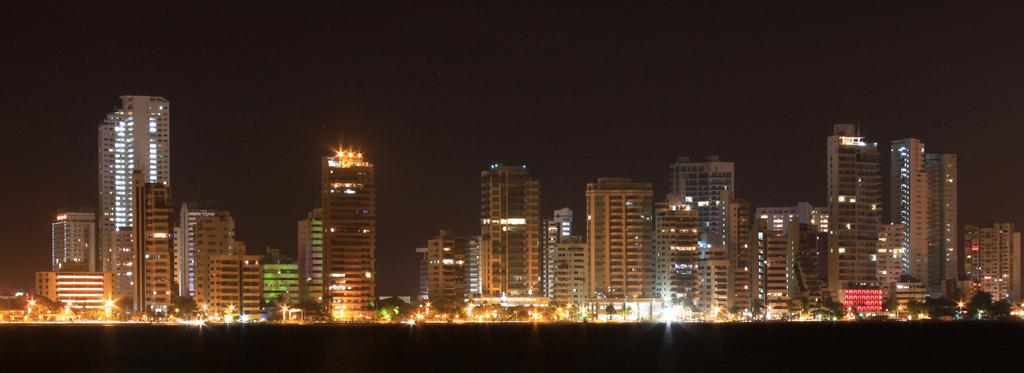What type of structures can be seen in the image? There are buildings in the image. What else is visible in the image besides the buildings? There are lights, vehicles, and trees in the image. What is the color of the sky in the background of the image? The sky is dark in the background of the image. What type of popcorn is being sold at the newsstand in the image? There is no newsstand or popcorn present in the image. What hobbies are the people in the image engaged in? The provided facts do not mention any people or their hobbies in the image. 